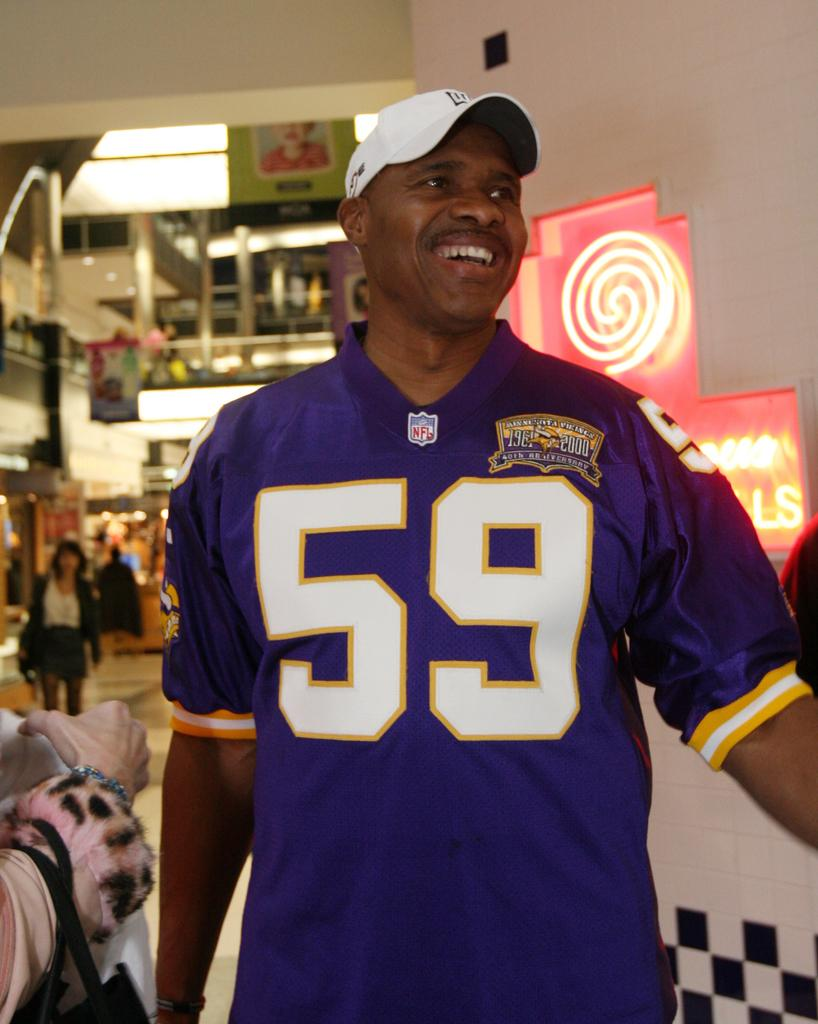<image>
Provide a brief description of the given image. Black man wearing a jersey from the NFL with number 59 wrote on it 